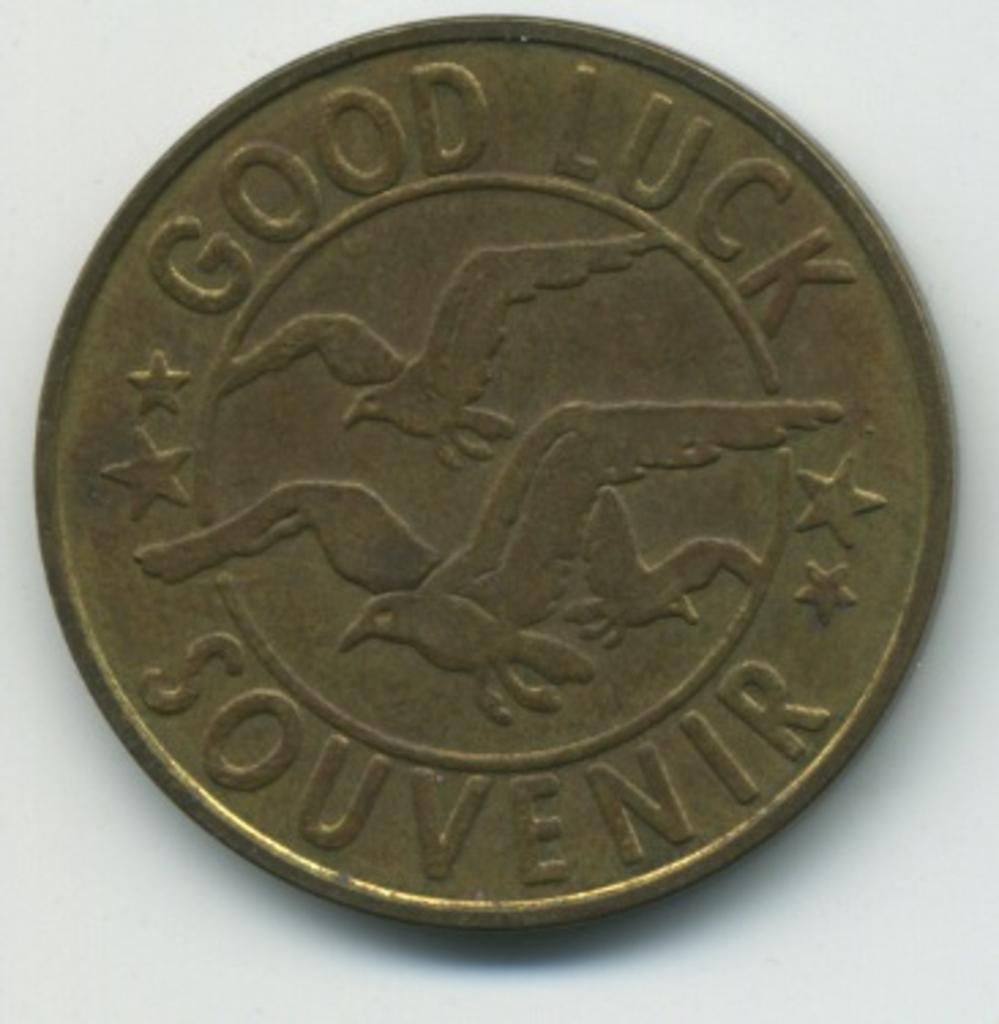<image>
Relay a brief, clear account of the picture shown. A gold coin with flying birds etched onto it reads GOOD LUCK SOUVENIR 